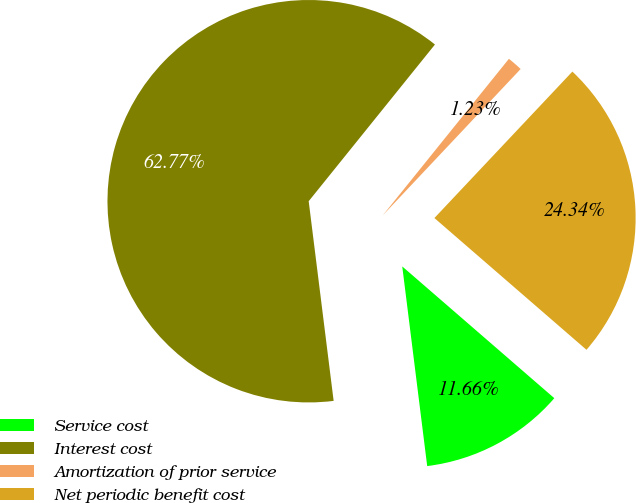<chart> <loc_0><loc_0><loc_500><loc_500><pie_chart><fcel>Service cost<fcel>Interest cost<fcel>Amortization of prior service<fcel>Net periodic benefit cost<nl><fcel>11.66%<fcel>62.78%<fcel>1.23%<fcel>24.34%<nl></chart> 